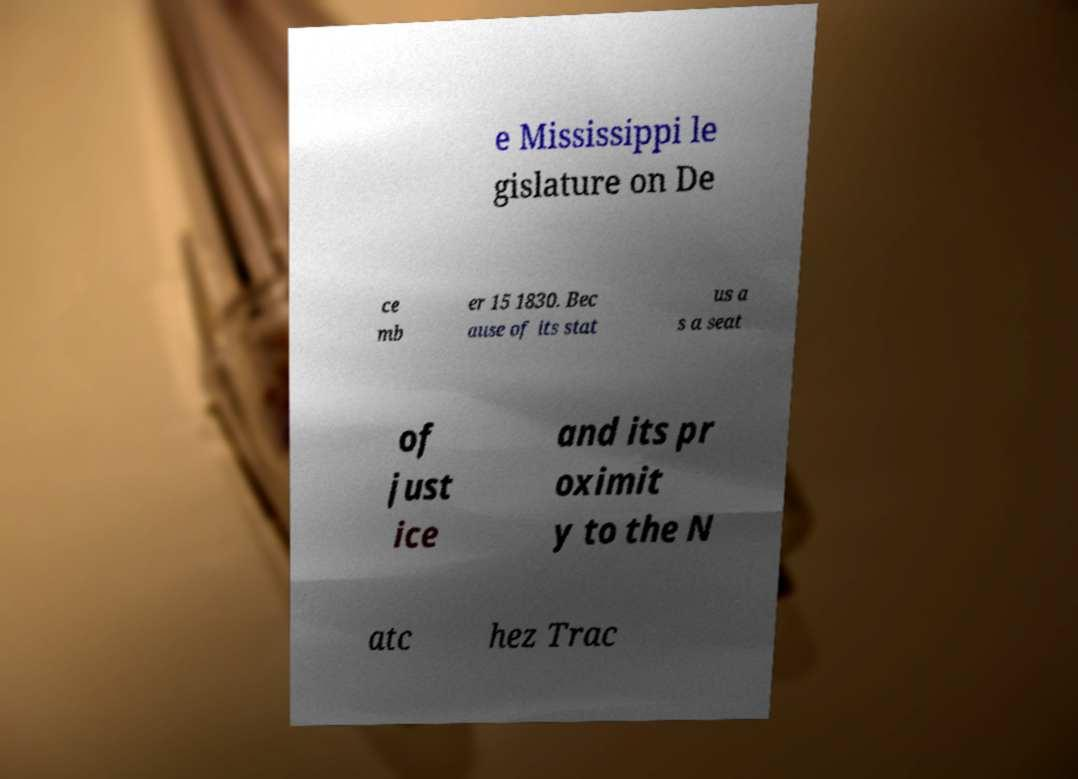Could you assist in decoding the text presented in this image and type it out clearly? e Mississippi le gislature on De ce mb er 15 1830. Bec ause of its stat us a s a seat of just ice and its pr oximit y to the N atc hez Trac 